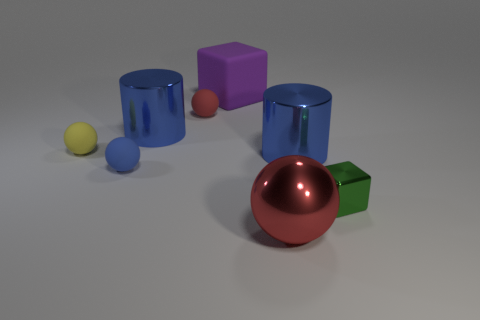How big is the purple block?
Offer a terse response. Large. How many things are tiny red cubes or metal spheres?
Your answer should be very brief. 1. How big is the blue cylinder left of the tiny red rubber ball?
Your answer should be very brief. Large. What is the color of the small sphere that is both right of the yellow sphere and behind the tiny blue rubber object?
Give a very brief answer. Red. Is the material of the large blue cylinder right of the rubber block the same as the purple cube?
Ensure brevity in your answer.  No. Is the color of the tiny block the same as the big metallic cylinder that is on the right side of the small red thing?
Your response must be concise. No. There is a large sphere; are there any big red things in front of it?
Make the answer very short. No. Is the size of the blue metallic thing that is in front of the yellow matte ball the same as the red thing on the left side of the big sphere?
Your answer should be very brief. No. Are there any purple rubber things that have the same size as the green metal cube?
Keep it short and to the point. No. There is a big metal object in front of the metal block; is its shape the same as the tiny green object?
Make the answer very short. No. 